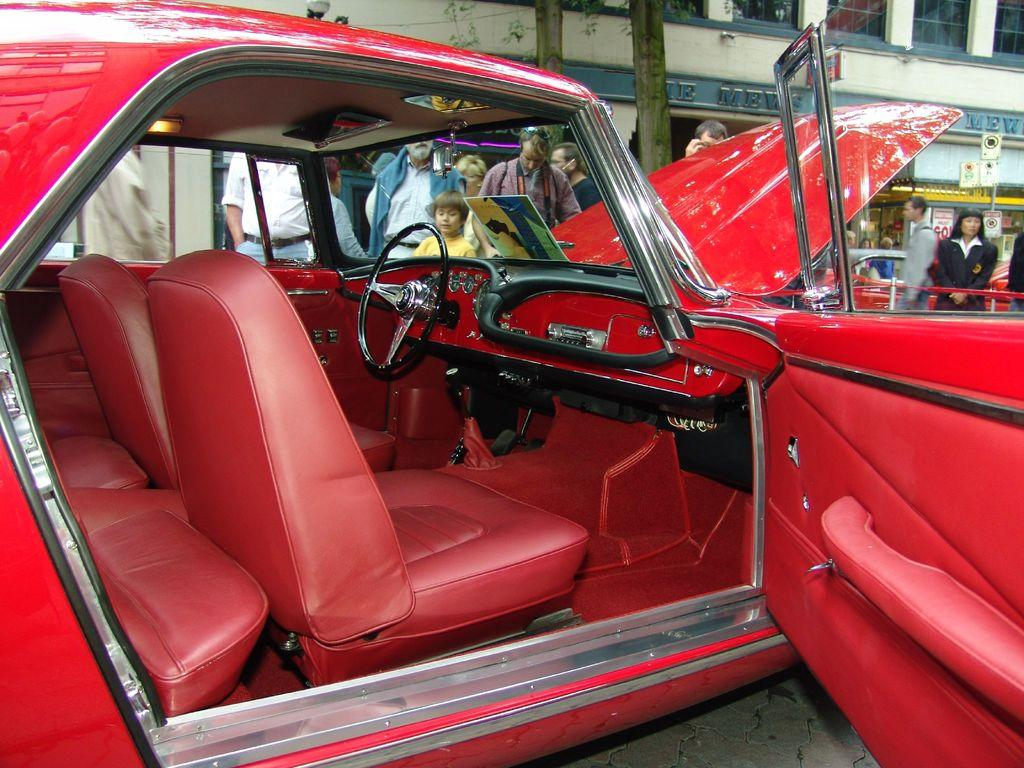What is the main subject of the image? There is a car in the image. What can be seen in the background of the image? There are many people in the background of the image. What type of structure is present in the image? There is a building with windows in the image. What additional information can be gathered from the building? There are names visible on the building. What type of plantation can be seen in the image? There is no plantation present in the image. Can you see the moon in the image? The image does not show the moon. How many toes are visible on the people in the image? The image does not show the toes of the people in the background. 